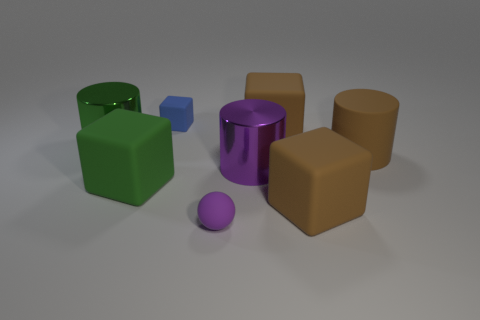Subtract all yellow cubes. Subtract all blue cylinders. How many cubes are left? 4 Add 1 blue things. How many objects exist? 9 Subtract all cylinders. How many objects are left? 5 Add 3 cubes. How many cubes exist? 7 Subtract 1 purple cylinders. How many objects are left? 7 Subtract all red matte spheres. Subtract all brown cubes. How many objects are left? 6 Add 1 cubes. How many cubes are left? 5 